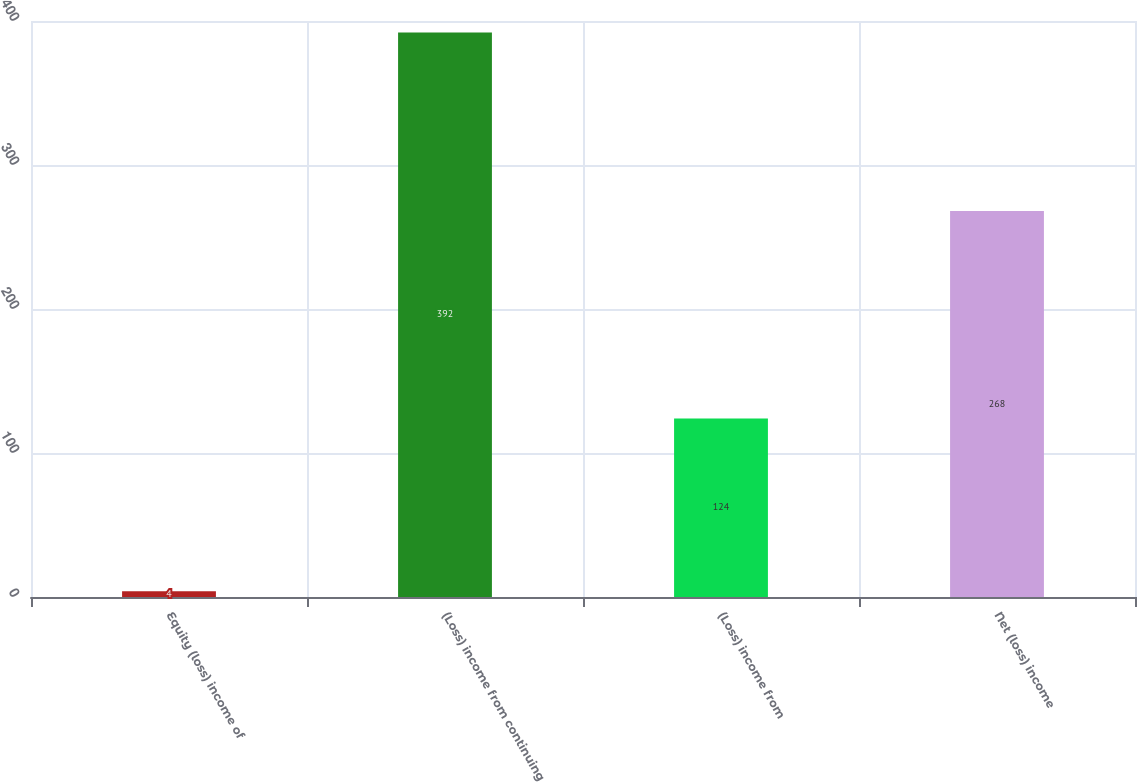Convert chart to OTSL. <chart><loc_0><loc_0><loc_500><loc_500><bar_chart><fcel>Equity (loss) income of<fcel>(Loss) income from continuing<fcel>(Loss) income from<fcel>Net (loss) income<nl><fcel>4<fcel>392<fcel>124<fcel>268<nl></chart> 